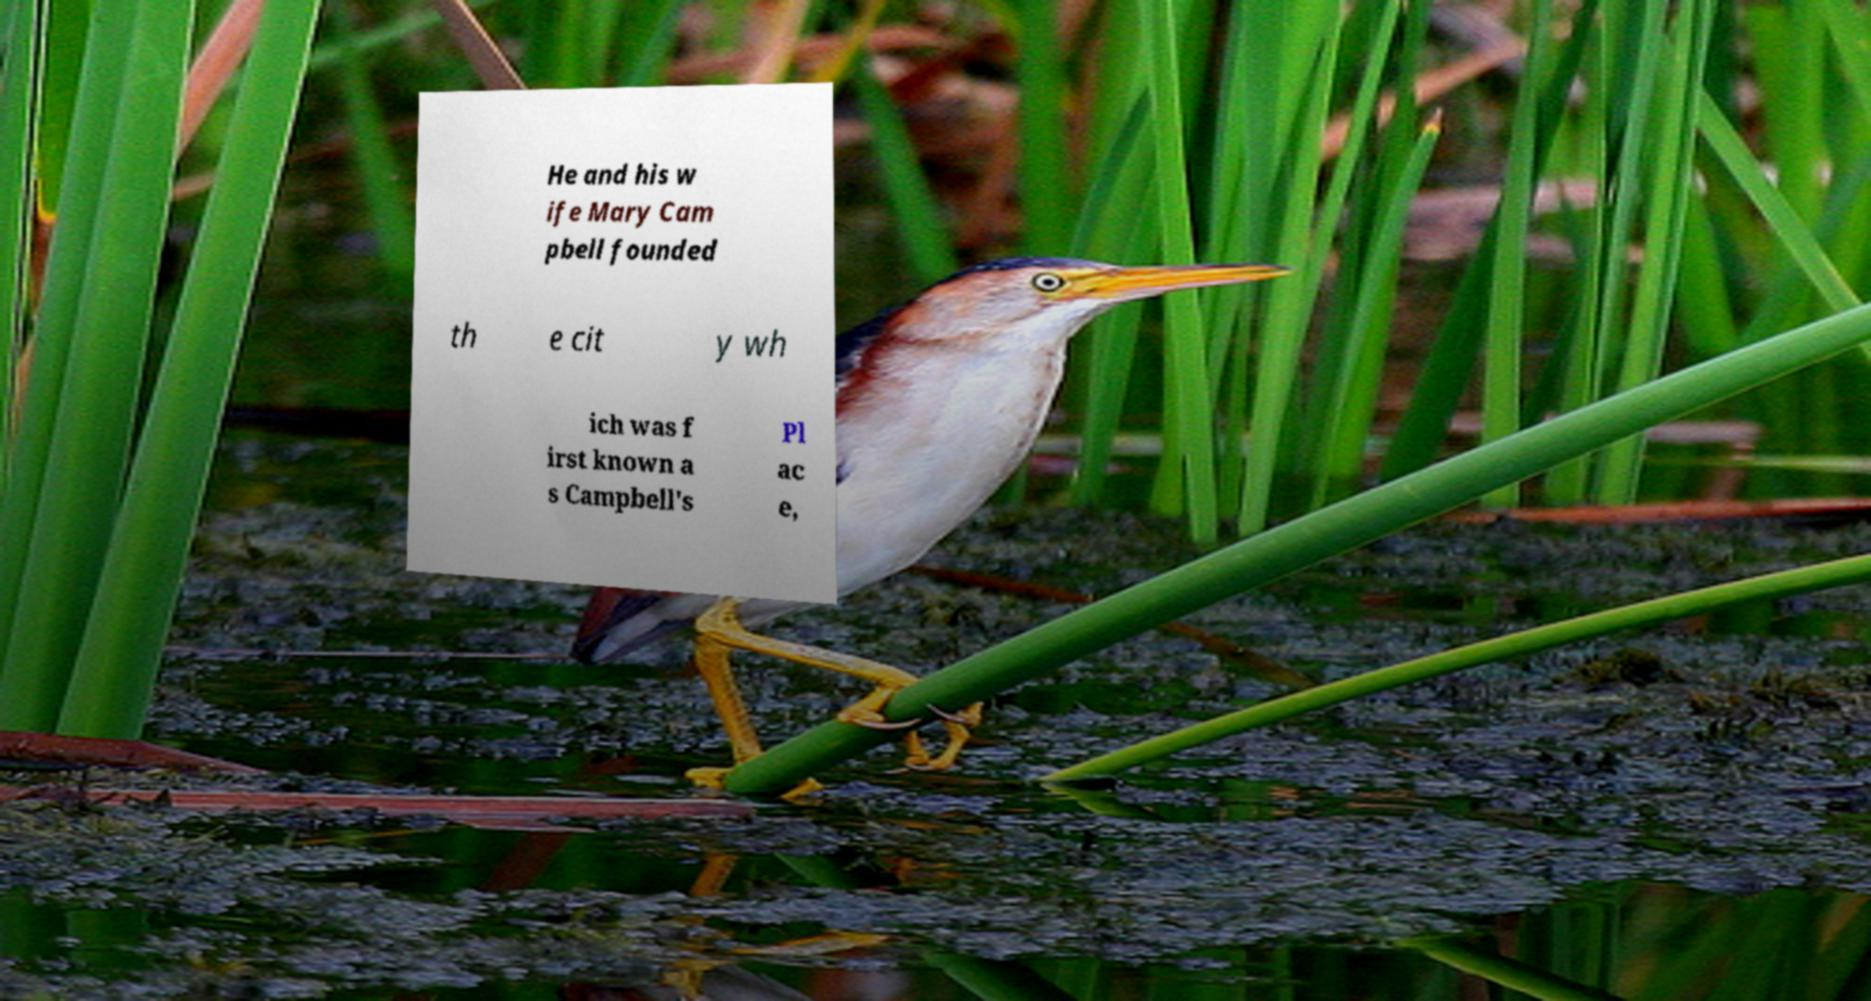Could you extract and type out the text from this image? He and his w ife Mary Cam pbell founded th e cit y wh ich was f irst known a s Campbell's Pl ac e, 